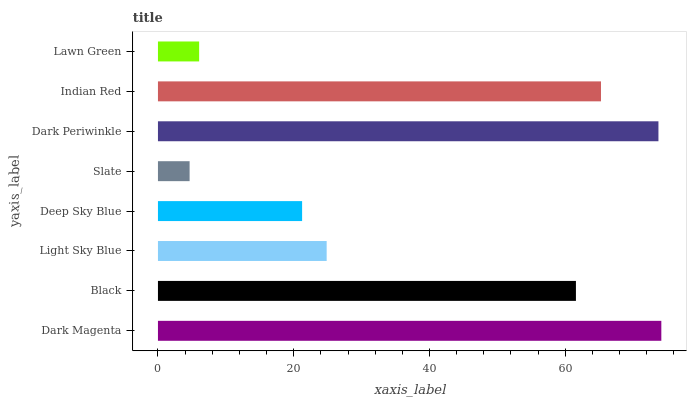Is Slate the minimum?
Answer yes or no. Yes. Is Dark Magenta the maximum?
Answer yes or no. Yes. Is Black the minimum?
Answer yes or no. No. Is Black the maximum?
Answer yes or no. No. Is Dark Magenta greater than Black?
Answer yes or no. Yes. Is Black less than Dark Magenta?
Answer yes or no. Yes. Is Black greater than Dark Magenta?
Answer yes or no. No. Is Dark Magenta less than Black?
Answer yes or no. No. Is Black the high median?
Answer yes or no. Yes. Is Light Sky Blue the low median?
Answer yes or no. Yes. Is Deep Sky Blue the high median?
Answer yes or no. No. Is Dark Magenta the low median?
Answer yes or no. No. 